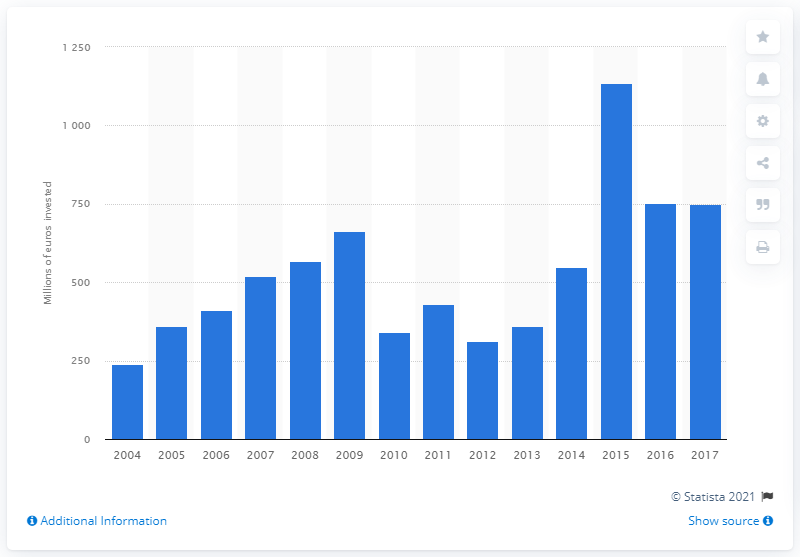Specify some key components in this picture. In 2017, a total of 749.85 million euros was invested in the road infrastructure of Slovakia. 